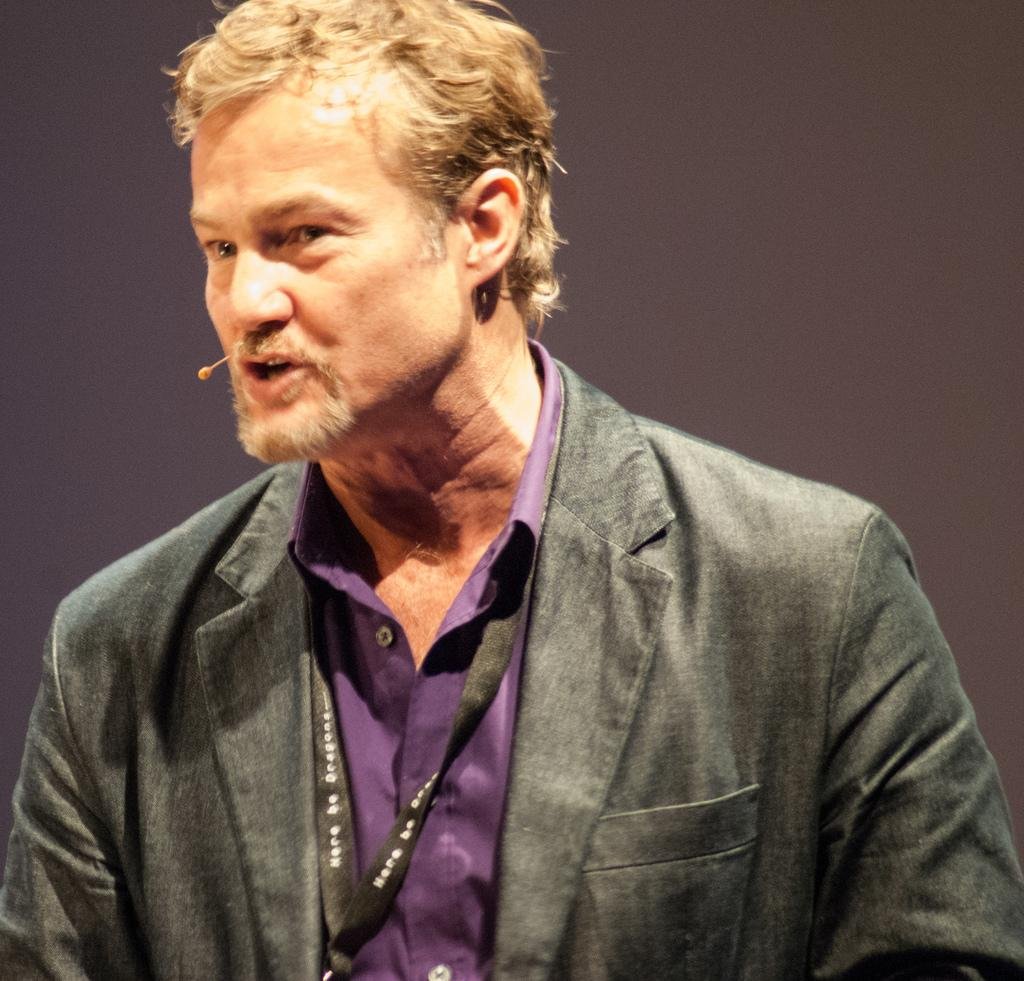What is present in the image? There is a person in the image. Can you describe the person's attire? The person is wearing a suit. Does the person have any additional features or accessories? Yes, the person has a tag. What is the name of the person's daughter in the image? There is no daughter present in the image, as it only features a person wearing a suit and having a tag. How many tigers can be seen in the image? There are no tigers present in the image. 